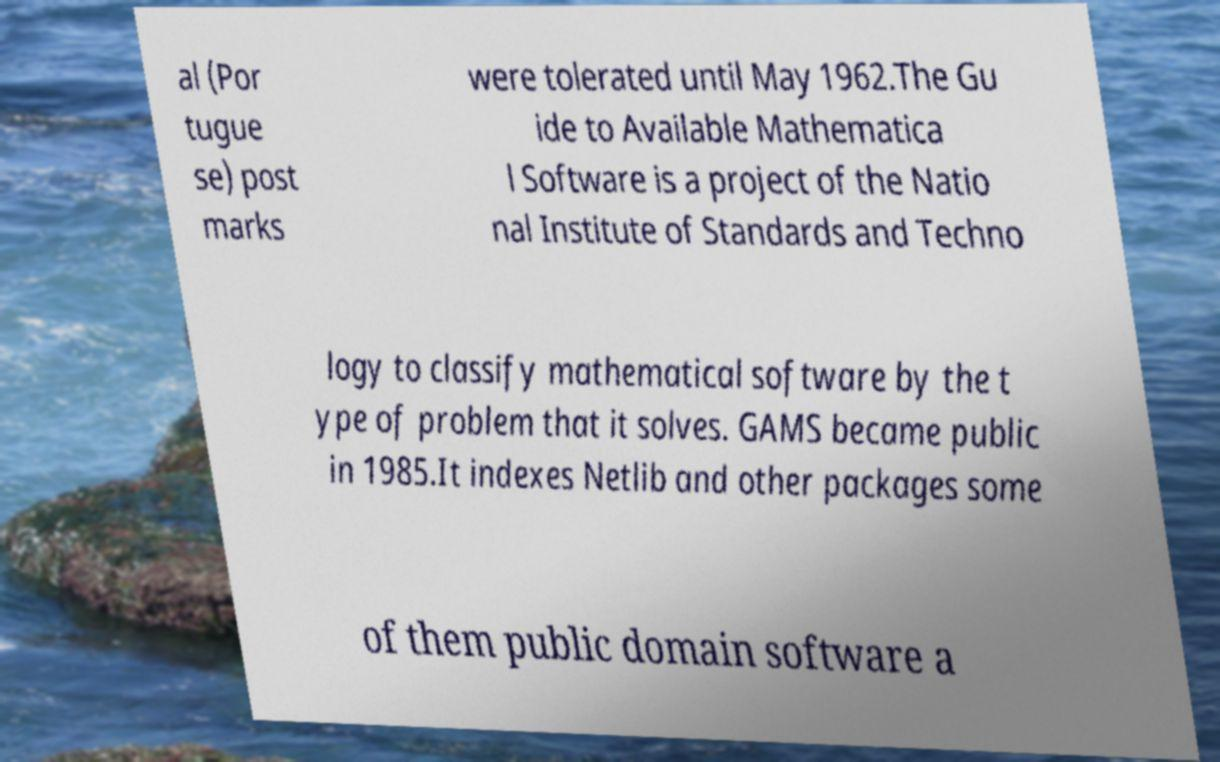Could you extract and type out the text from this image? al (Por tugue se) post marks were tolerated until May 1962.The Gu ide to Available Mathematica l Software is a project of the Natio nal Institute of Standards and Techno logy to classify mathematical software by the t ype of problem that it solves. GAMS became public in 1985.It indexes Netlib and other packages some of them public domain software a 